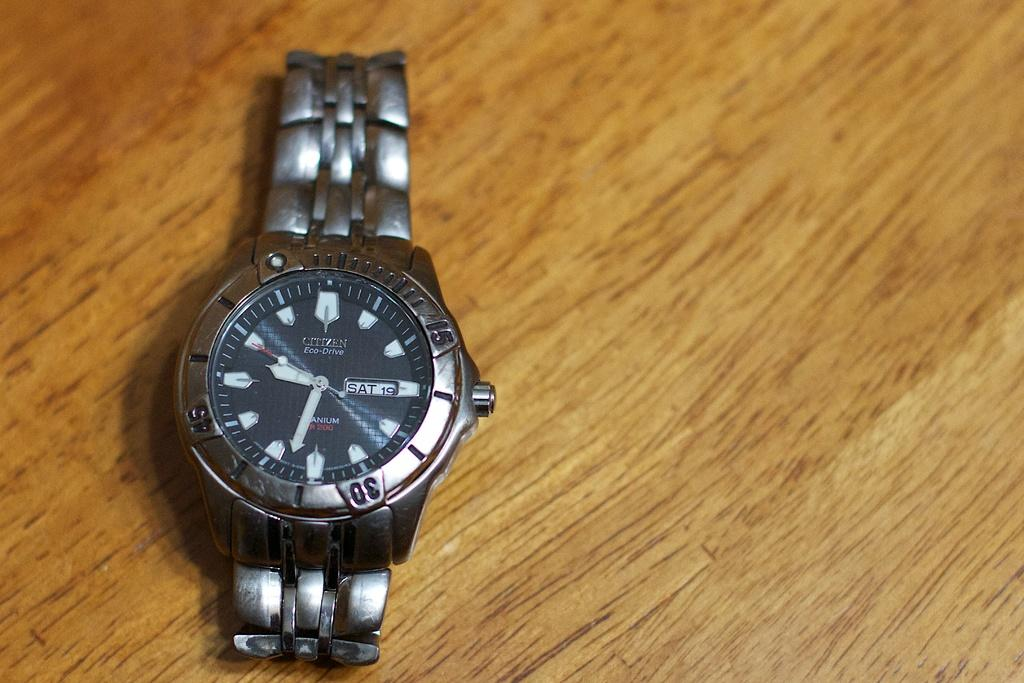Provide a one-sentence caption for the provided image. The brand of watch on the table is a Citizen. 